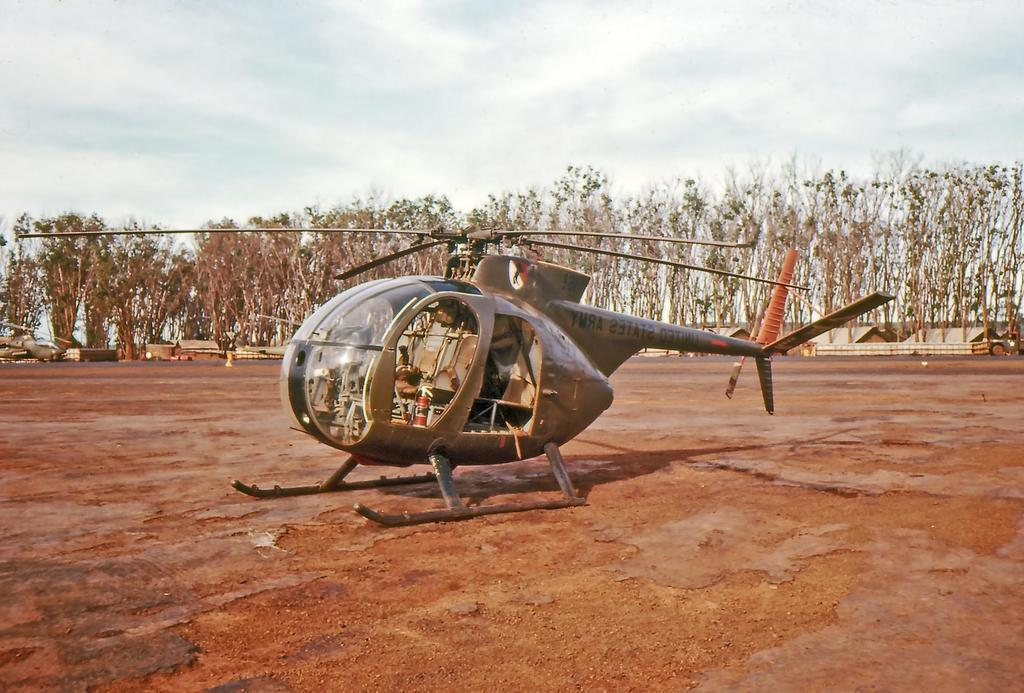What is on the ground in the image? There is a plan on the ground in the image. What can be seen in the distance in the image? There are houses and trees in the background of the image. What type of clouds can be seen in the image? There are no clouds visible in the image; it only shows a plan on the ground and houses and trees in the background. 